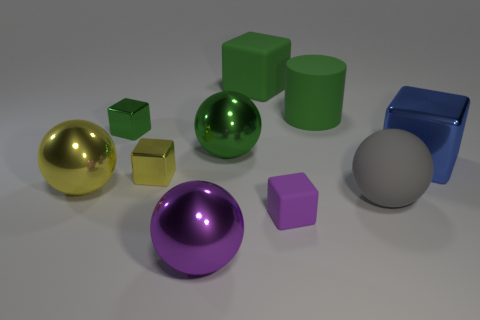What is the shape of the tiny object that is the same color as the cylinder?
Give a very brief answer. Cube. What number of small yellow cubes have the same material as the large green cylinder?
Make the answer very short. 0. There is a big ball that is on the right side of the sphere that is behind the large yellow metal ball; are there any yellow shiny blocks that are in front of it?
Provide a short and direct response. No. How many cylinders are small purple objects or yellow things?
Offer a very short reply. 0. Does the small yellow thing have the same shape as the large shiny object to the right of the green ball?
Keep it short and to the point. Yes. Is the number of green metal blocks that are on the right side of the gray rubber sphere less than the number of big blue blocks?
Provide a short and direct response. Yes. Are there any large gray rubber things behind the green metallic ball?
Keep it short and to the point. No. Is there a large blue thing that has the same shape as the small yellow shiny thing?
Give a very brief answer. Yes. What shape is the blue metallic thing that is the same size as the yellow metal sphere?
Your answer should be compact. Cube. What number of objects are things on the right side of the green metal block or purple shiny things?
Provide a succinct answer. 8. 